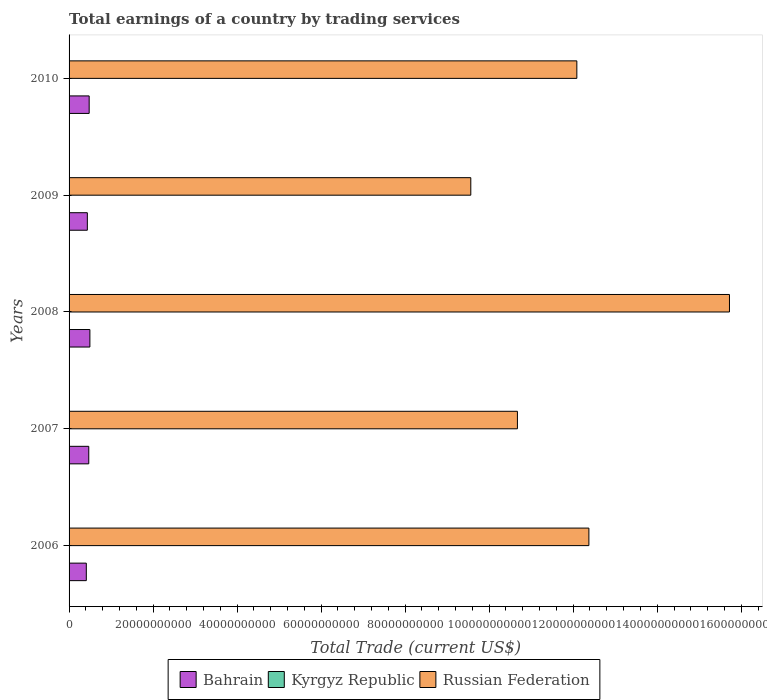How many different coloured bars are there?
Your answer should be compact. 2. Are the number of bars on each tick of the Y-axis equal?
Keep it short and to the point. Yes. How many bars are there on the 5th tick from the top?
Offer a terse response. 2. What is the total earnings in Russian Federation in 2008?
Ensure brevity in your answer.  1.57e+11. Across all years, what is the maximum total earnings in Bahrain?
Provide a short and direct response. 4.96e+09. In which year was the total earnings in Bahrain maximum?
Ensure brevity in your answer.  2008. What is the difference between the total earnings in Russian Federation in 2006 and that in 2010?
Give a very brief answer. 2.86e+09. What is the difference between the total earnings in Kyrgyz Republic in 2010 and the total earnings in Bahrain in 2008?
Ensure brevity in your answer.  -4.96e+09. What is the average total earnings in Russian Federation per year?
Keep it short and to the point. 1.21e+11. In the year 2009, what is the difference between the total earnings in Bahrain and total earnings in Russian Federation?
Ensure brevity in your answer.  -9.13e+1. What is the ratio of the total earnings in Bahrain in 2006 to that in 2010?
Give a very brief answer. 0.86. Is the total earnings in Russian Federation in 2008 less than that in 2009?
Provide a short and direct response. No. Is the difference between the total earnings in Bahrain in 2006 and 2007 greater than the difference between the total earnings in Russian Federation in 2006 and 2007?
Give a very brief answer. No. What is the difference between the highest and the second highest total earnings in Bahrain?
Provide a short and direct response. 1.70e+08. What is the difference between the highest and the lowest total earnings in Russian Federation?
Your answer should be very brief. 6.16e+1. In how many years, is the total earnings in Bahrain greater than the average total earnings in Bahrain taken over all years?
Offer a terse response. 3. Is the sum of the total earnings in Bahrain in 2007 and 2009 greater than the maximum total earnings in Russian Federation across all years?
Ensure brevity in your answer.  No. Is it the case that in every year, the sum of the total earnings in Bahrain and total earnings in Russian Federation is greater than the total earnings in Kyrgyz Republic?
Offer a terse response. Yes. How many bars are there?
Provide a succinct answer. 10. Are all the bars in the graph horizontal?
Provide a succinct answer. Yes. What is the difference between two consecutive major ticks on the X-axis?
Keep it short and to the point. 2.00e+1. Are the values on the major ticks of X-axis written in scientific E-notation?
Your answer should be very brief. No. Does the graph contain any zero values?
Ensure brevity in your answer.  Yes. Where does the legend appear in the graph?
Your answer should be very brief. Bottom center. How many legend labels are there?
Your response must be concise. 3. How are the legend labels stacked?
Offer a very short reply. Horizontal. What is the title of the graph?
Your answer should be compact. Total earnings of a country by trading services. Does "Equatorial Guinea" appear as one of the legend labels in the graph?
Give a very brief answer. No. What is the label or title of the X-axis?
Ensure brevity in your answer.  Total Trade (current US$). What is the label or title of the Y-axis?
Your answer should be very brief. Years. What is the Total Trade (current US$) in Bahrain in 2006?
Offer a terse response. 4.10e+09. What is the Total Trade (current US$) of Kyrgyz Republic in 2006?
Make the answer very short. 0. What is the Total Trade (current US$) of Russian Federation in 2006?
Offer a terse response. 1.24e+11. What is the Total Trade (current US$) in Bahrain in 2007?
Ensure brevity in your answer.  4.69e+09. What is the Total Trade (current US$) in Kyrgyz Republic in 2007?
Your answer should be compact. 0. What is the Total Trade (current US$) in Russian Federation in 2007?
Your answer should be very brief. 1.07e+11. What is the Total Trade (current US$) in Bahrain in 2008?
Give a very brief answer. 4.96e+09. What is the Total Trade (current US$) in Kyrgyz Republic in 2008?
Give a very brief answer. 0. What is the Total Trade (current US$) in Russian Federation in 2008?
Ensure brevity in your answer.  1.57e+11. What is the Total Trade (current US$) of Bahrain in 2009?
Ensure brevity in your answer.  4.35e+09. What is the Total Trade (current US$) in Kyrgyz Republic in 2009?
Your answer should be very brief. 0. What is the Total Trade (current US$) in Russian Federation in 2009?
Offer a very short reply. 9.56e+1. What is the Total Trade (current US$) of Bahrain in 2010?
Offer a very short reply. 4.78e+09. What is the Total Trade (current US$) in Kyrgyz Republic in 2010?
Make the answer very short. 0. What is the Total Trade (current US$) in Russian Federation in 2010?
Offer a very short reply. 1.21e+11. Across all years, what is the maximum Total Trade (current US$) of Bahrain?
Offer a terse response. 4.96e+09. Across all years, what is the maximum Total Trade (current US$) of Russian Federation?
Provide a succinct answer. 1.57e+11. Across all years, what is the minimum Total Trade (current US$) of Bahrain?
Your response must be concise. 4.10e+09. Across all years, what is the minimum Total Trade (current US$) in Russian Federation?
Offer a very short reply. 9.56e+1. What is the total Total Trade (current US$) in Bahrain in the graph?
Your answer should be compact. 2.29e+1. What is the total Total Trade (current US$) of Kyrgyz Republic in the graph?
Provide a succinct answer. 0. What is the total Total Trade (current US$) in Russian Federation in the graph?
Make the answer very short. 6.04e+11. What is the difference between the Total Trade (current US$) of Bahrain in 2006 and that in 2007?
Make the answer very short. -5.85e+08. What is the difference between the Total Trade (current US$) in Russian Federation in 2006 and that in 2007?
Ensure brevity in your answer.  1.70e+1. What is the difference between the Total Trade (current US$) in Bahrain in 2006 and that in 2008?
Give a very brief answer. -8.52e+08. What is the difference between the Total Trade (current US$) of Russian Federation in 2006 and that in 2008?
Your answer should be compact. -3.35e+1. What is the difference between the Total Trade (current US$) of Bahrain in 2006 and that in 2009?
Your response must be concise. -2.48e+08. What is the difference between the Total Trade (current US$) in Russian Federation in 2006 and that in 2009?
Give a very brief answer. 2.81e+1. What is the difference between the Total Trade (current US$) of Bahrain in 2006 and that in 2010?
Give a very brief answer. -6.82e+08. What is the difference between the Total Trade (current US$) in Russian Federation in 2006 and that in 2010?
Ensure brevity in your answer.  2.86e+09. What is the difference between the Total Trade (current US$) of Bahrain in 2007 and that in 2008?
Ensure brevity in your answer.  -2.67e+08. What is the difference between the Total Trade (current US$) in Russian Federation in 2007 and that in 2008?
Your answer should be very brief. -5.05e+1. What is the difference between the Total Trade (current US$) in Bahrain in 2007 and that in 2009?
Ensure brevity in your answer.  3.37e+08. What is the difference between the Total Trade (current US$) of Russian Federation in 2007 and that in 2009?
Ensure brevity in your answer.  1.11e+1. What is the difference between the Total Trade (current US$) in Bahrain in 2007 and that in 2010?
Your response must be concise. -9.68e+07. What is the difference between the Total Trade (current US$) in Russian Federation in 2007 and that in 2010?
Ensure brevity in your answer.  -1.41e+1. What is the difference between the Total Trade (current US$) of Bahrain in 2008 and that in 2009?
Provide a succinct answer. 6.04e+08. What is the difference between the Total Trade (current US$) in Russian Federation in 2008 and that in 2009?
Your response must be concise. 6.16e+1. What is the difference between the Total Trade (current US$) of Bahrain in 2008 and that in 2010?
Provide a succinct answer. 1.70e+08. What is the difference between the Total Trade (current US$) in Russian Federation in 2008 and that in 2010?
Provide a succinct answer. 3.63e+1. What is the difference between the Total Trade (current US$) of Bahrain in 2009 and that in 2010?
Your response must be concise. -4.34e+08. What is the difference between the Total Trade (current US$) of Russian Federation in 2009 and that in 2010?
Keep it short and to the point. -2.52e+1. What is the difference between the Total Trade (current US$) in Bahrain in 2006 and the Total Trade (current US$) in Russian Federation in 2007?
Your response must be concise. -1.03e+11. What is the difference between the Total Trade (current US$) in Bahrain in 2006 and the Total Trade (current US$) in Russian Federation in 2008?
Offer a very short reply. -1.53e+11. What is the difference between the Total Trade (current US$) of Bahrain in 2006 and the Total Trade (current US$) of Russian Federation in 2009?
Provide a succinct answer. -9.15e+1. What is the difference between the Total Trade (current US$) of Bahrain in 2006 and the Total Trade (current US$) of Russian Federation in 2010?
Provide a short and direct response. -1.17e+11. What is the difference between the Total Trade (current US$) in Bahrain in 2007 and the Total Trade (current US$) in Russian Federation in 2008?
Ensure brevity in your answer.  -1.53e+11. What is the difference between the Total Trade (current US$) of Bahrain in 2007 and the Total Trade (current US$) of Russian Federation in 2009?
Ensure brevity in your answer.  -9.09e+1. What is the difference between the Total Trade (current US$) in Bahrain in 2007 and the Total Trade (current US$) in Russian Federation in 2010?
Your answer should be compact. -1.16e+11. What is the difference between the Total Trade (current US$) in Bahrain in 2008 and the Total Trade (current US$) in Russian Federation in 2009?
Offer a very short reply. -9.07e+1. What is the difference between the Total Trade (current US$) in Bahrain in 2008 and the Total Trade (current US$) in Russian Federation in 2010?
Provide a short and direct response. -1.16e+11. What is the difference between the Total Trade (current US$) in Bahrain in 2009 and the Total Trade (current US$) in Russian Federation in 2010?
Your answer should be compact. -1.17e+11. What is the average Total Trade (current US$) in Bahrain per year?
Provide a succinct answer. 4.58e+09. What is the average Total Trade (current US$) in Kyrgyz Republic per year?
Your answer should be compact. 0. What is the average Total Trade (current US$) in Russian Federation per year?
Make the answer very short. 1.21e+11. In the year 2006, what is the difference between the Total Trade (current US$) of Bahrain and Total Trade (current US$) of Russian Federation?
Provide a succinct answer. -1.20e+11. In the year 2007, what is the difference between the Total Trade (current US$) of Bahrain and Total Trade (current US$) of Russian Federation?
Offer a very short reply. -1.02e+11. In the year 2008, what is the difference between the Total Trade (current US$) in Bahrain and Total Trade (current US$) in Russian Federation?
Offer a terse response. -1.52e+11. In the year 2009, what is the difference between the Total Trade (current US$) in Bahrain and Total Trade (current US$) in Russian Federation?
Give a very brief answer. -9.13e+1. In the year 2010, what is the difference between the Total Trade (current US$) in Bahrain and Total Trade (current US$) in Russian Federation?
Offer a very short reply. -1.16e+11. What is the ratio of the Total Trade (current US$) in Bahrain in 2006 to that in 2007?
Make the answer very short. 0.88. What is the ratio of the Total Trade (current US$) of Russian Federation in 2006 to that in 2007?
Offer a very short reply. 1.16. What is the ratio of the Total Trade (current US$) in Bahrain in 2006 to that in 2008?
Offer a terse response. 0.83. What is the ratio of the Total Trade (current US$) in Russian Federation in 2006 to that in 2008?
Give a very brief answer. 0.79. What is the ratio of the Total Trade (current US$) in Bahrain in 2006 to that in 2009?
Provide a succinct answer. 0.94. What is the ratio of the Total Trade (current US$) in Russian Federation in 2006 to that in 2009?
Your answer should be compact. 1.29. What is the ratio of the Total Trade (current US$) in Bahrain in 2006 to that in 2010?
Your response must be concise. 0.86. What is the ratio of the Total Trade (current US$) in Russian Federation in 2006 to that in 2010?
Make the answer very short. 1.02. What is the ratio of the Total Trade (current US$) in Bahrain in 2007 to that in 2008?
Provide a short and direct response. 0.95. What is the ratio of the Total Trade (current US$) in Russian Federation in 2007 to that in 2008?
Make the answer very short. 0.68. What is the ratio of the Total Trade (current US$) of Bahrain in 2007 to that in 2009?
Your answer should be very brief. 1.08. What is the ratio of the Total Trade (current US$) of Russian Federation in 2007 to that in 2009?
Your answer should be very brief. 1.12. What is the ratio of the Total Trade (current US$) in Bahrain in 2007 to that in 2010?
Your response must be concise. 0.98. What is the ratio of the Total Trade (current US$) in Russian Federation in 2007 to that in 2010?
Give a very brief answer. 0.88. What is the ratio of the Total Trade (current US$) in Bahrain in 2008 to that in 2009?
Provide a succinct answer. 1.14. What is the ratio of the Total Trade (current US$) in Russian Federation in 2008 to that in 2009?
Ensure brevity in your answer.  1.64. What is the ratio of the Total Trade (current US$) in Bahrain in 2008 to that in 2010?
Provide a succinct answer. 1.04. What is the ratio of the Total Trade (current US$) of Russian Federation in 2008 to that in 2010?
Ensure brevity in your answer.  1.3. What is the ratio of the Total Trade (current US$) in Bahrain in 2009 to that in 2010?
Make the answer very short. 0.91. What is the ratio of the Total Trade (current US$) of Russian Federation in 2009 to that in 2010?
Your answer should be very brief. 0.79. What is the difference between the highest and the second highest Total Trade (current US$) in Bahrain?
Keep it short and to the point. 1.70e+08. What is the difference between the highest and the second highest Total Trade (current US$) in Russian Federation?
Your answer should be compact. 3.35e+1. What is the difference between the highest and the lowest Total Trade (current US$) of Bahrain?
Your answer should be compact. 8.52e+08. What is the difference between the highest and the lowest Total Trade (current US$) in Russian Federation?
Ensure brevity in your answer.  6.16e+1. 